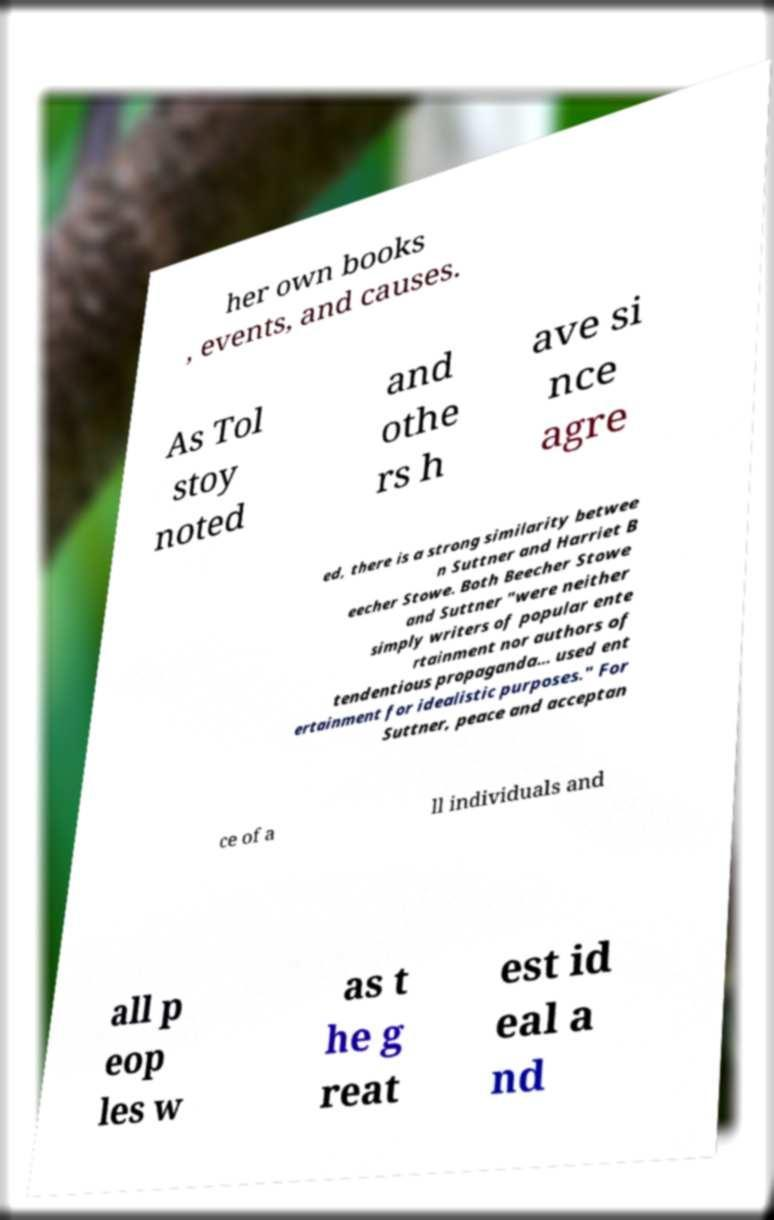Please read and relay the text visible in this image. What does it say? her own books , events, and causes. As Tol stoy noted and othe rs h ave si nce agre ed, there is a strong similarity betwee n Suttner and Harriet B eecher Stowe. Both Beecher Stowe and Suttner "were neither simply writers of popular ente rtainment nor authors of tendentious propaganda... used ent ertainment for idealistic purposes." For Suttner, peace and acceptan ce of a ll individuals and all p eop les w as t he g reat est id eal a nd 